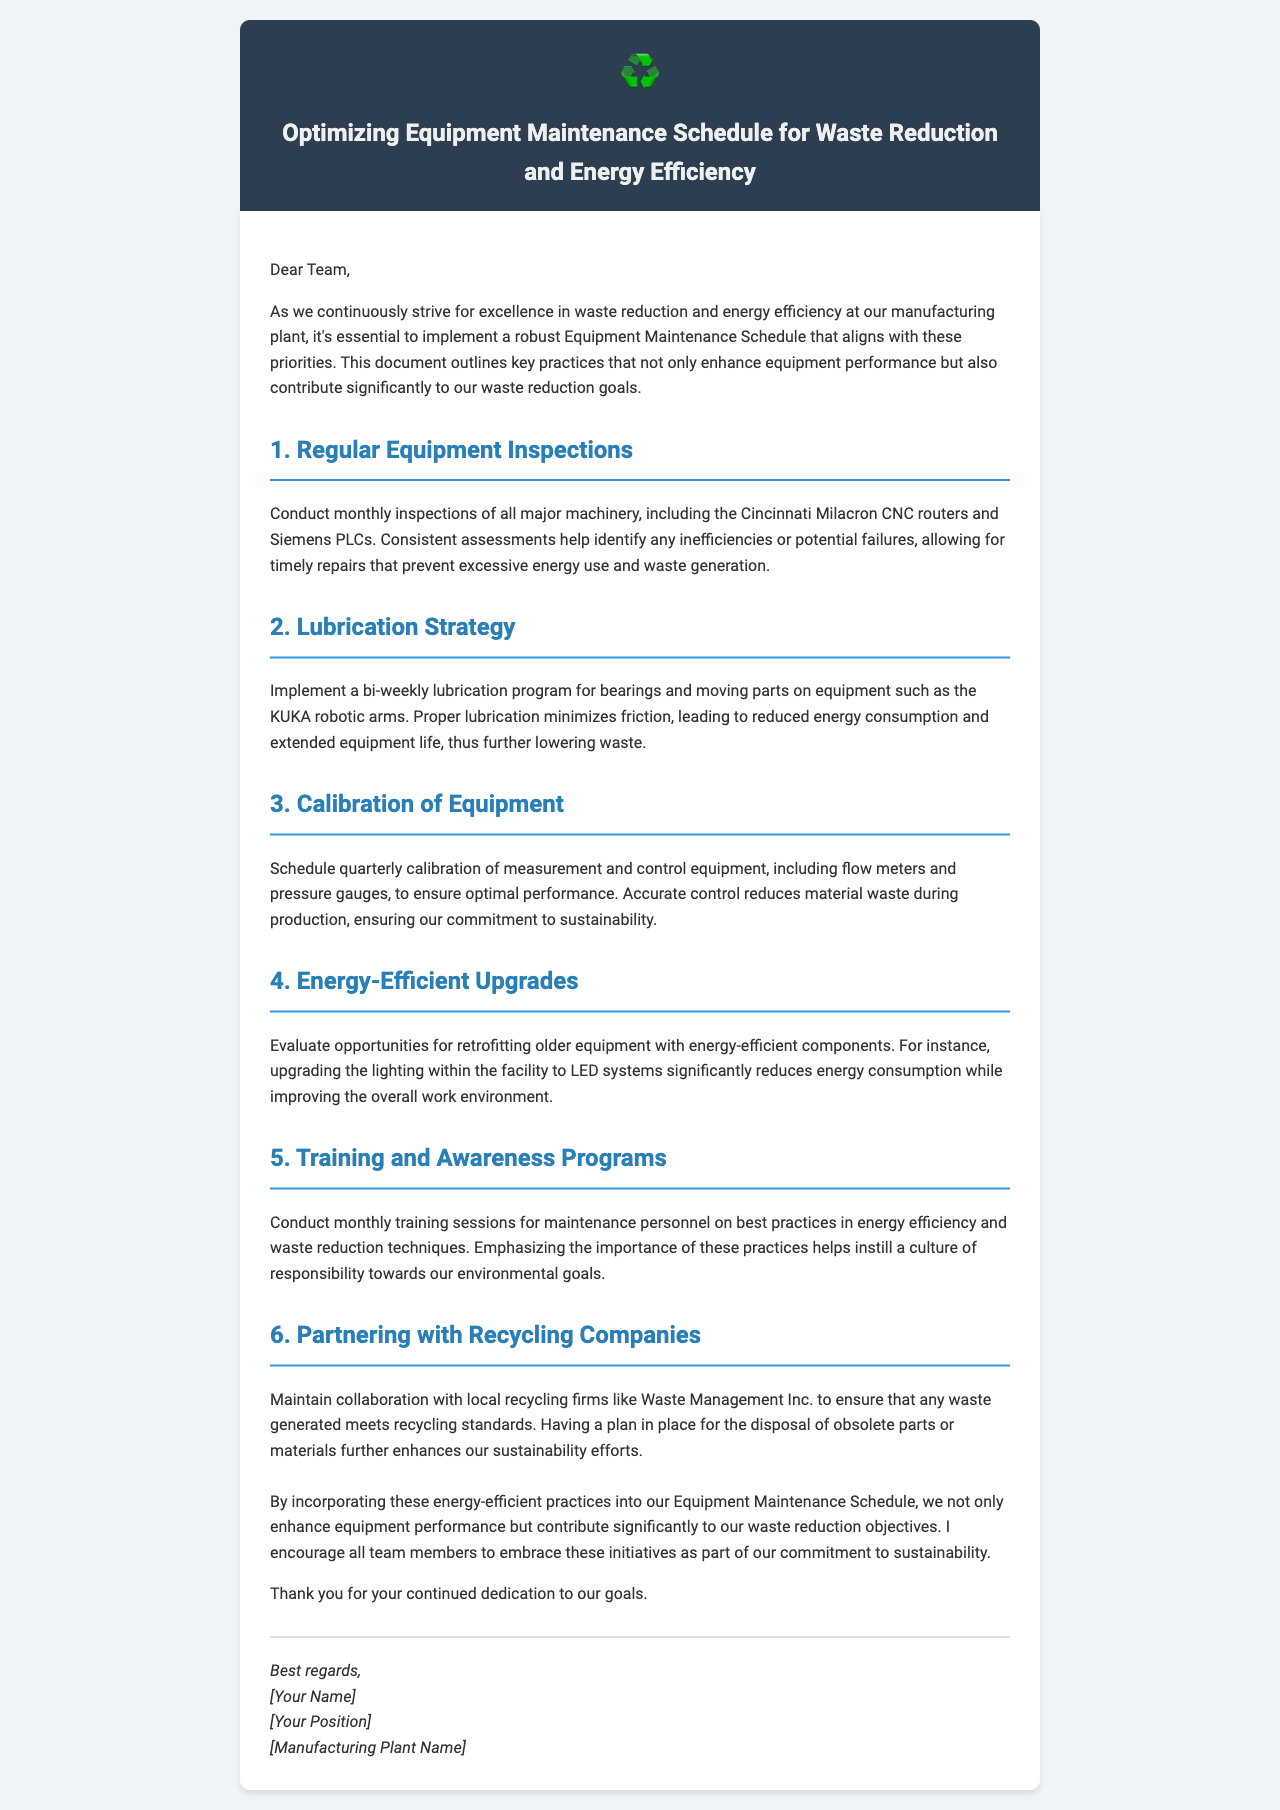what is the title of the document? The title of the document is found in the header section, summarizing its purpose.
Answer: Optimizing Equipment Maintenance Schedule for Waste Reduction and Energy Efficiency how often should major machinery be inspected? The document specifies the frequency of inspections in the first section regarding regular equipment inspections.
Answer: monthly which equipment requires a bi-weekly lubrication program? The lubrication strategy section mentions specific equipment for lubrication.
Answer: KUKA robotic arms how often should calibration of measurement equipment be scheduled? The calibration section outlines the frequency for calibration operations.
Answer: quarterly who should conduct the training sessions on best practices? The document mentions the intended audience for training sessions in the training section.
Answer: maintenance personnel what is emphasized in the training sessions? The document outlines the focus of the training sessions for maintenance personnel.
Answer: energy efficiency and waste reduction techniques which company is mentioned as a partner for recycling? The document states the name of the local recycling firm being collaborated with.
Answer: Waste Management Inc what is the main benefit of retrofitting older equipment? The document describes the advantages of making upgrades to older equipment.
Answer: energy-efficient components what should be included in the Equipment Maintenance Schedule? The document clearly outlines important practices to be incorporated into the schedule.
Answer: energy-efficient practices 